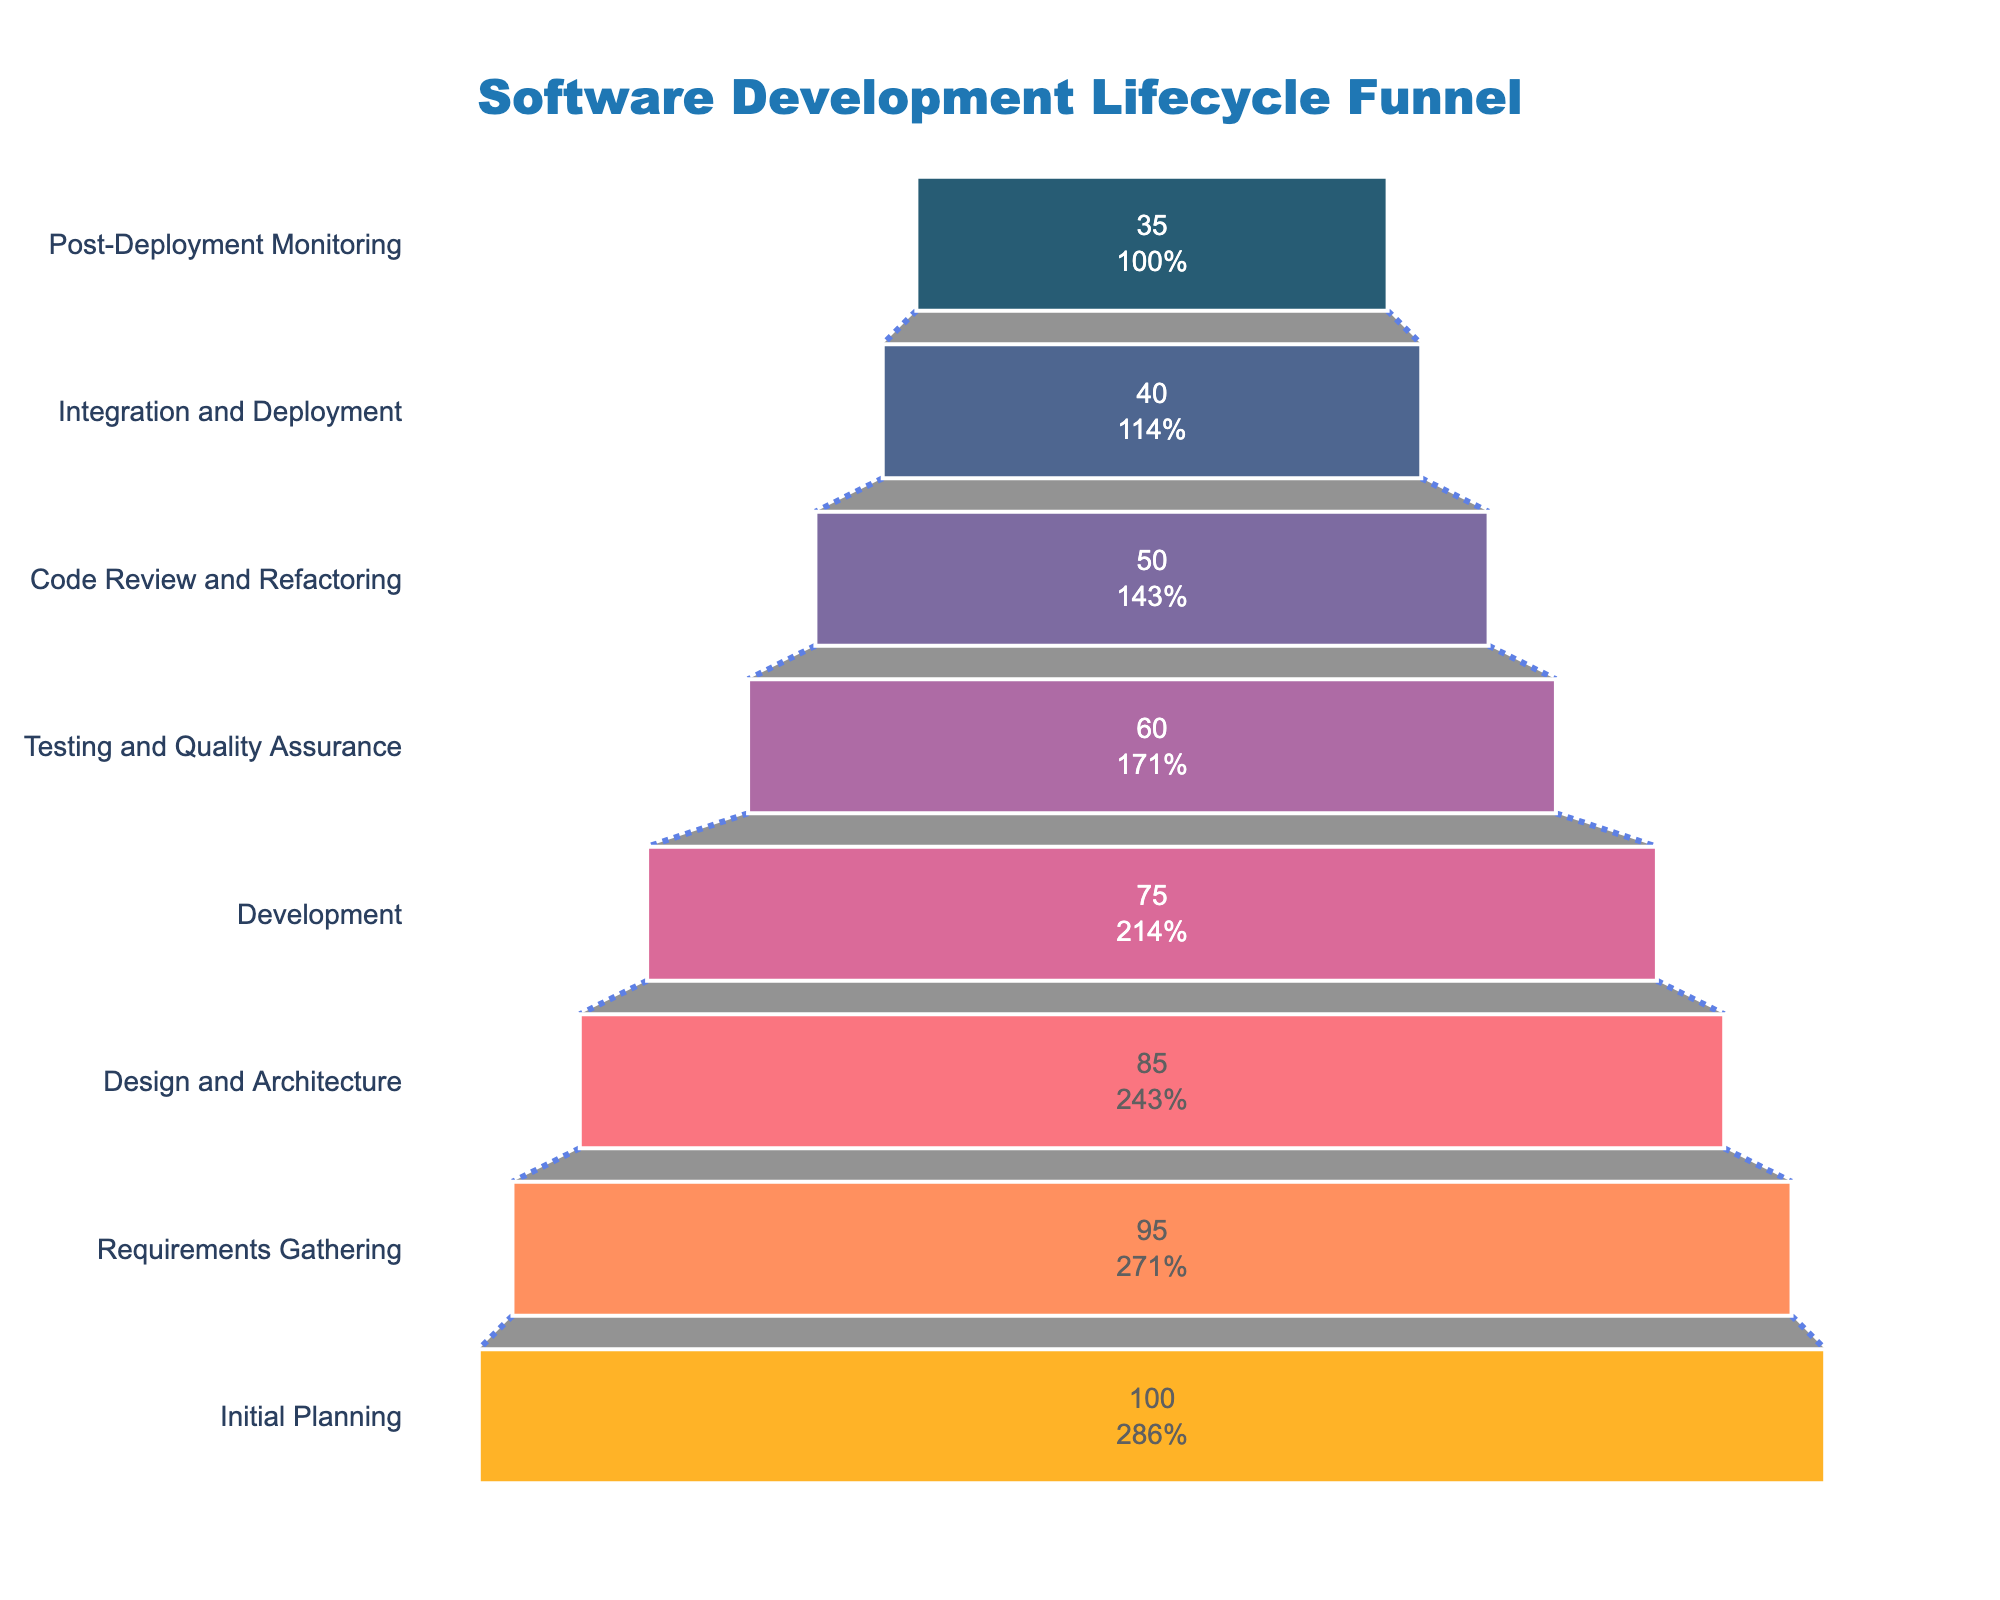What's the title of the funnel chart? The title is found at the top of the chart and is designed to provide an overview of what the chart is about. Here it clearly states the subject.
Answer: Software Development Lifecycle Funnel How many stages are represented in the funnel? Count the unique stages listed on the vertical axis from top to bottom.
Answer: 8 Which stage has the highest conversion rate? The stage with the highest conversion rate is represented by the widest section at the top of the funnel.
Answer: Initial Planning Which stage shows the largest drop in the conversion rate from its preceding stage? Calculate the differences in conversion rates between each stage and the one preceding it. The stage with the largest negative difference indicates the largest drop. The drop between Testing and Quality Assurance (60) to Code Review and Refactoring (50) is 10, which is the largest.
Answer: Testing and Quality Assurance to Code Review and Refactoring What's the total reduction in conversion rate from Initial Planning to Post-Deployment Monitoring? Subtract the conversion rate of the final stage from the first stage: 100 (Initial Planning) - 35 (Post-Deployment Monitoring).
Answer: 65 Which stage has a conversion rate closest to the average conversion rate of all stages? Calculate the average by adding all conversion rates and dividing by the number of stages. Then, find the stage whose conversion rate is closest to this average. The average is (100 + 95 + 85 + 75 + 60 + 50 + 40 + 35) / 8 = 305 / 8 = 67.5. The closest rate is 60.
Answer: Testing and Quality Assurance How does the color coding help in distinguishing different stages? Each stage is represented by a distinct color, aiding in visually separating them and helping users quickly identify different stages. Colors vary from dark blue to bright yellow.
Answer: By distinct colors What percentage of the initial conversion rate is achieved in Post-Deployment Monitoring? Divide the conversion rate of Post-Deployment Monitoring by the conversion rate of Initial Planning and multiply by 100 to get the percentage: (35 / 100) * 100.
Answer: 35% What is the combined conversion rate of the stages before Development? Sum the conversion rates of the stages before Development: Initial Planning (100) + Requirements Gathering (95) + Design and Architecture (85).
Answer: 280 What is the percentage decrease from Requirements Gathering to Design and Architecture? Calculate the difference between the conversion rates of Requirements Gathering (95) and Design and Architecture (85), then divide by the conversion rate of Requirements Gathering and multiply by 100: ((95 - 85) / 95) * 100.
Answer: 10.53% 